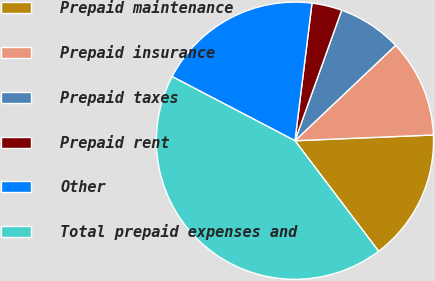<chart> <loc_0><loc_0><loc_500><loc_500><pie_chart><fcel>Prepaid maintenance<fcel>Prepaid insurance<fcel>Prepaid taxes<fcel>Prepaid rent<fcel>Other<fcel>Total prepaid expenses and<nl><fcel>15.35%<fcel>11.41%<fcel>7.46%<fcel>3.51%<fcel>19.3%<fcel>42.97%<nl></chart> 